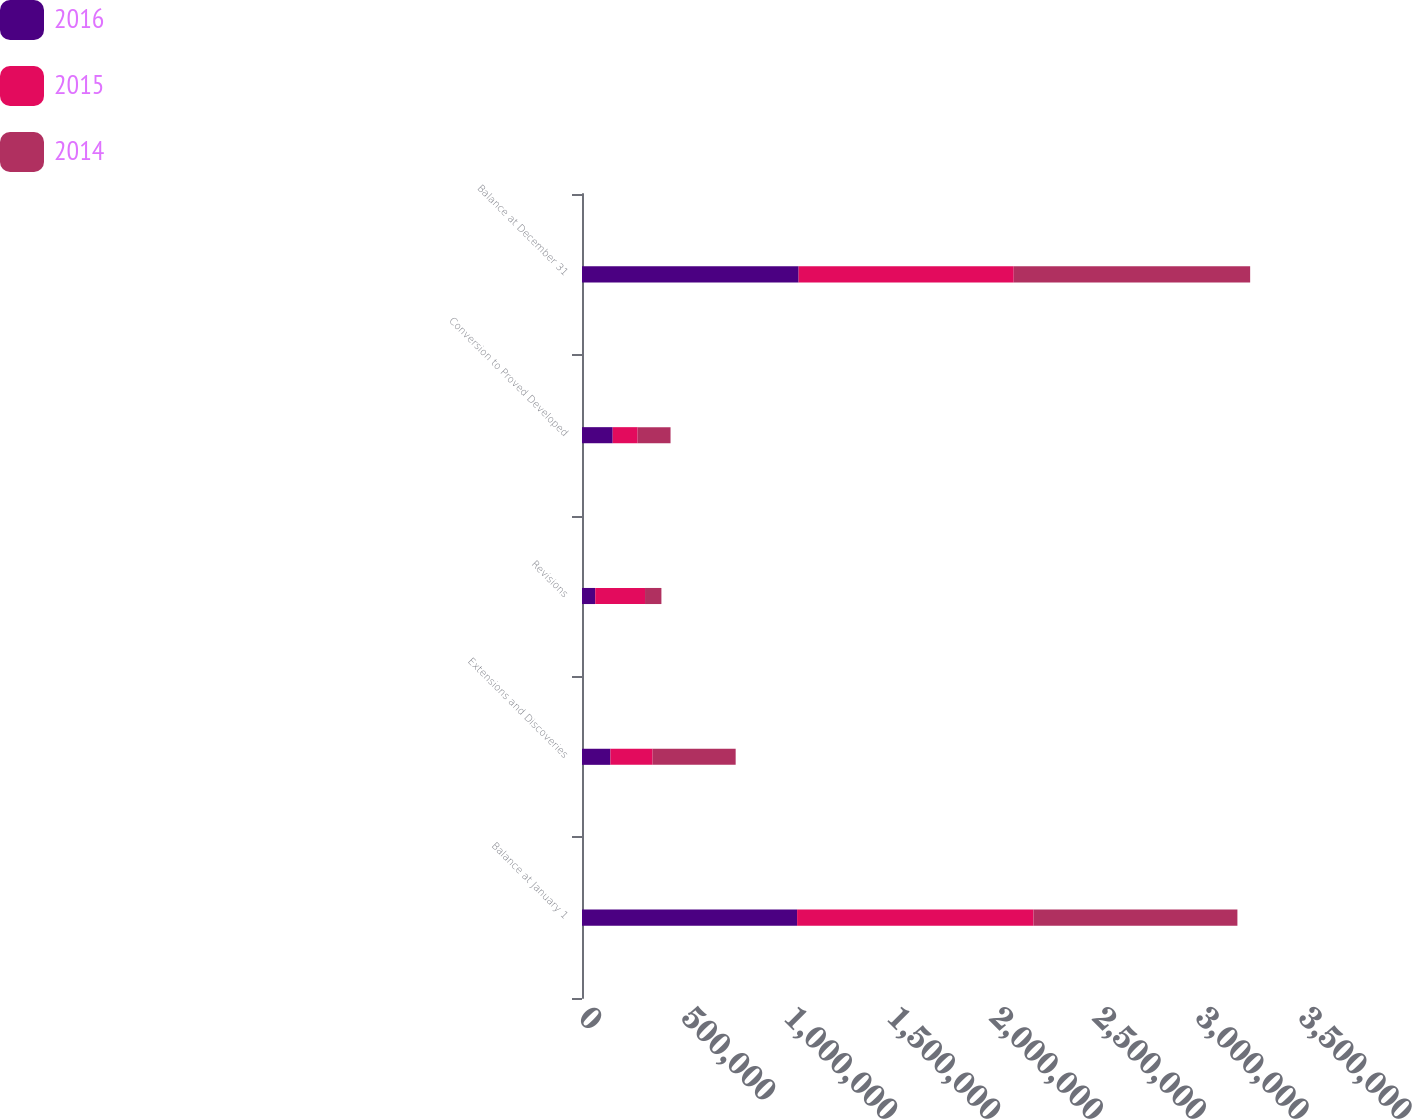Convert chart to OTSL. <chart><loc_0><loc_0><loc_500><loc_500><stacked_bar_chart><ecel><fcel>Balance at January 1<fcel>Extensions and Discoveries<fcel>Revisions<fcel>Conversion to Proved Developed<fcel>Balance at December 31<nl><fcel>2016<fcel>1.04564e+06<fcel>138101<fcel>64413<fcel>149210<fcel>1.05303e+06<nl><fcel>2015<fcel>1.14931e+06<fcel>205152<fcel>241973<fcel>121306<fcel>1.04564e+06<nl><fcel>2014<fcel>991067<fcel>403713<fcel>79630<fcel>159904<fcel>1.14931e+06<nl></chart> 